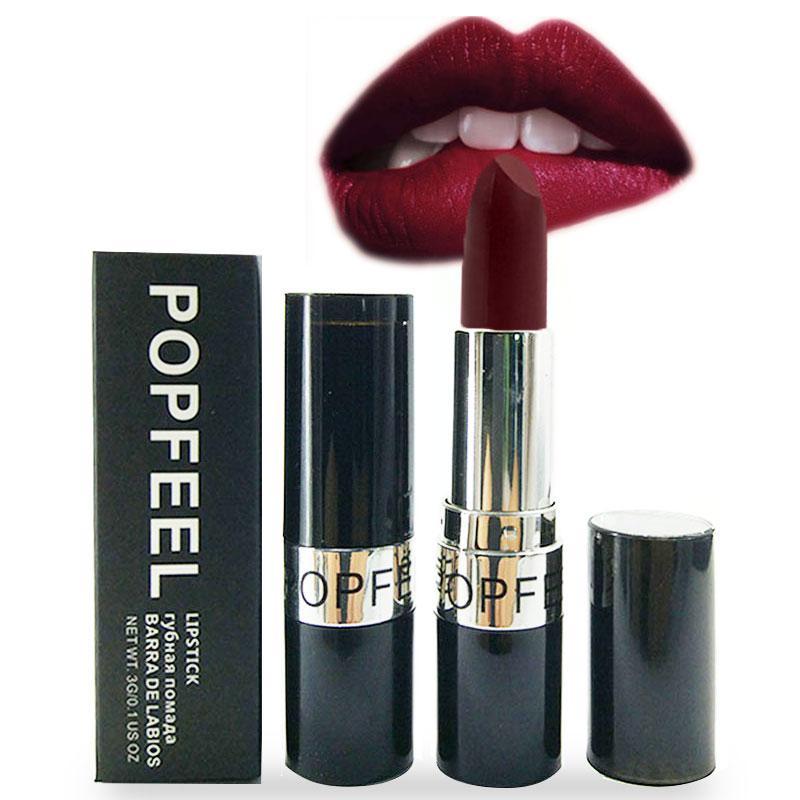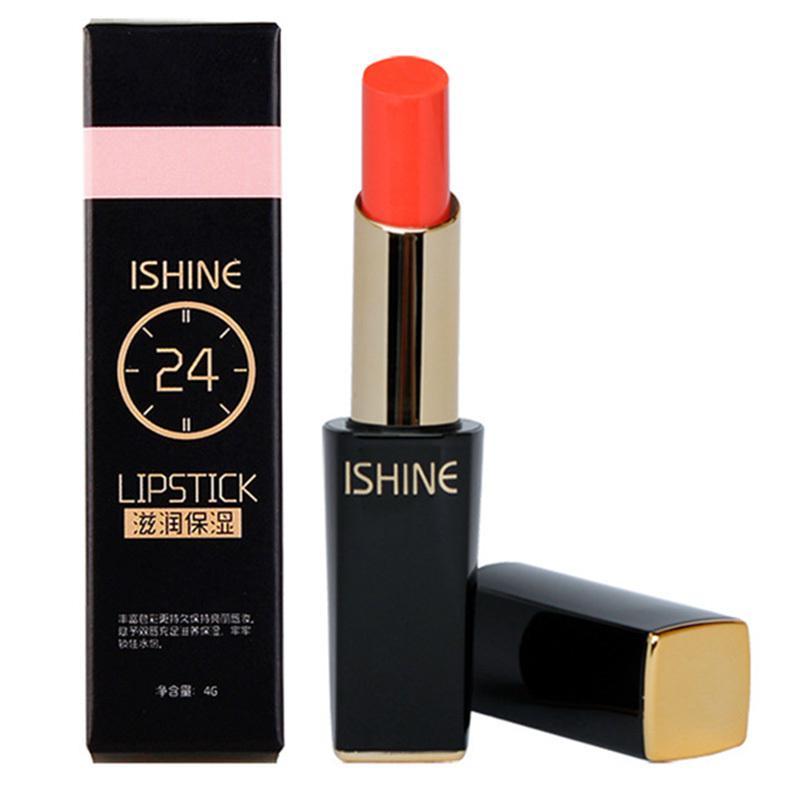The first image is the image on the left, the second image is the image on the right. Examine the images to the left and right. Is the description "At least one lipstick has an odd phallus shape." accurate? Answer yes or no. No. 